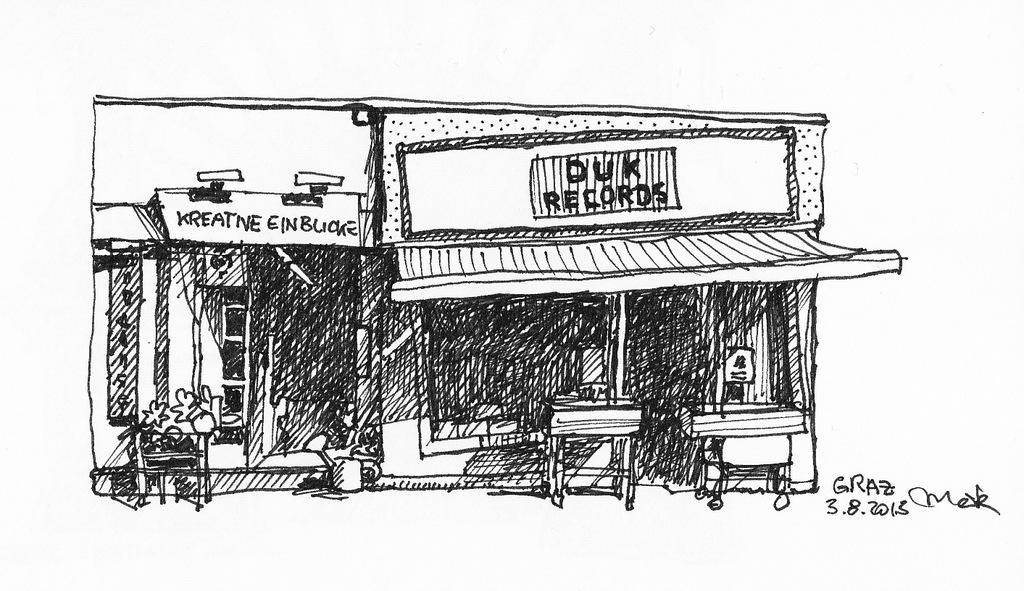What is the main subject of the drawing in the image? There is a drawing of a building in the center of the image. What type of furniture is depicted in the drawing? There are tables depicted in the drawing. Are there any other objects or features in the drawing? Yes, there are other objects in the drawing. What can be seen in addition to the drawing? There is text present in the image. What type of winter clothing is worn by the building in the image? There is no winter clothing present in the image, as it is a drawing of a building and not a person. 